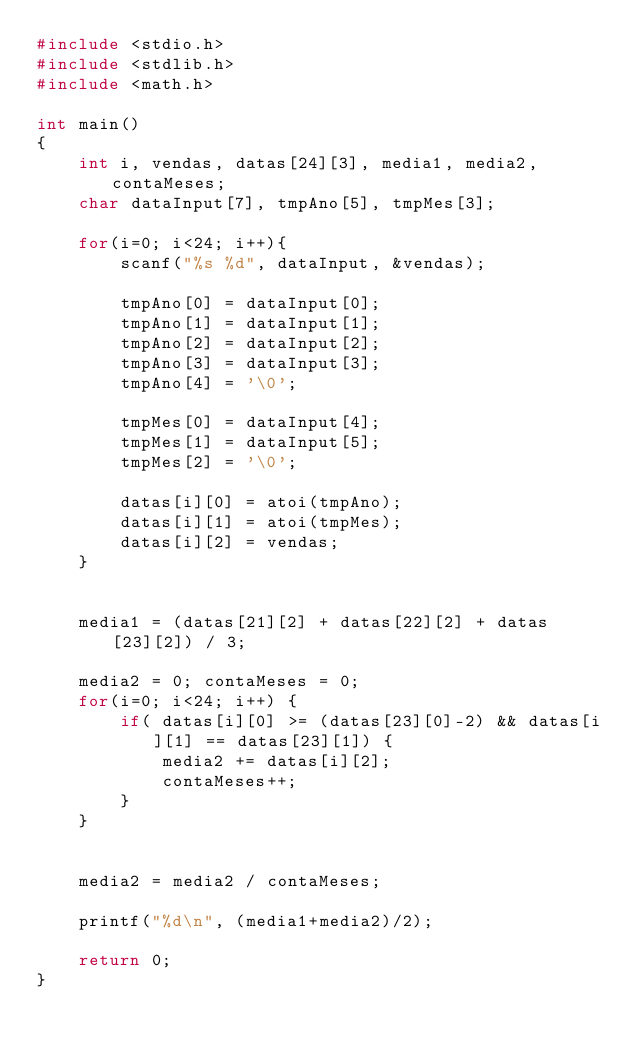<code> <loc_0><loc_0><loc_500><loc_500><_C_>#include <stdio.h>
#include <stdlib.h>
#include <math.h>

int main()
{
    int i, vendas, datas[24][3], media1, media2, contaMeses;
    char dataInput[7], tmpAno[5], tmpMes[3];

    for(i=0; i<24; i++){
        scanf("%s %d", dataInput, &vendas);

        tmpAno[0] = dataInput[0];
        tmpAno[1] = dataInput[1];
        tmpAno[2] = dataInput[2];
        tmpAno[3] = dataInput[3];
        tmpAno[4] = '\0';

        tmpMes[0] = dataInput[4];
        tmpMes[1] = dataInput[5];
        tmpMes[2] = '\0';

        datas[i][0] = atoi(tmpAno);
        datas[i][1] = atoi(tmpMes);
        datas[i][2] = vendas;
    }


    media1 = (datas[21][2] + datas[22][2] + datas[23][2]) / 3;

    media2 = 0; contaMeses = 0;
    for(i=0; i<24; i++) {
        if( datas[i][0] >= (datas[23][0]-2) && datas[i][1] == datas[23][1]) {
            media2 += datas[i][2];
            contaMeses++;
        }
    }


    media2 = media2 / contaMeses;

    printf("%d\n", (media1+media2)/2);

    return 0;
}
</code> 